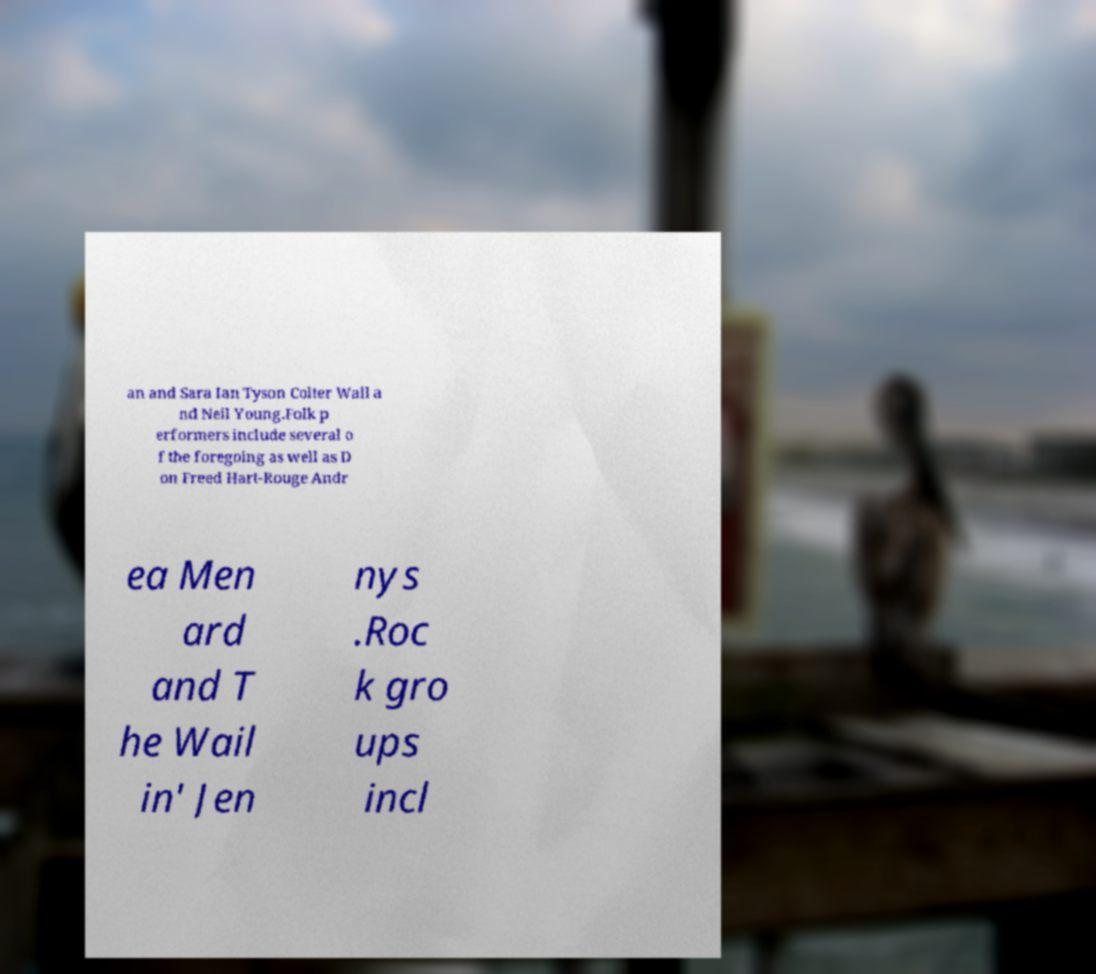Please read and relay the text visible in this image. What does it say? an and Sara Ian Tyson Colter Wall a nd Neil Young.Folk p erformers include several o f the foregoing as well as D on Freed Hart-Rouge Andr ea Men ard and T he Wail in' Jen nys .Roc k gro ups incl 